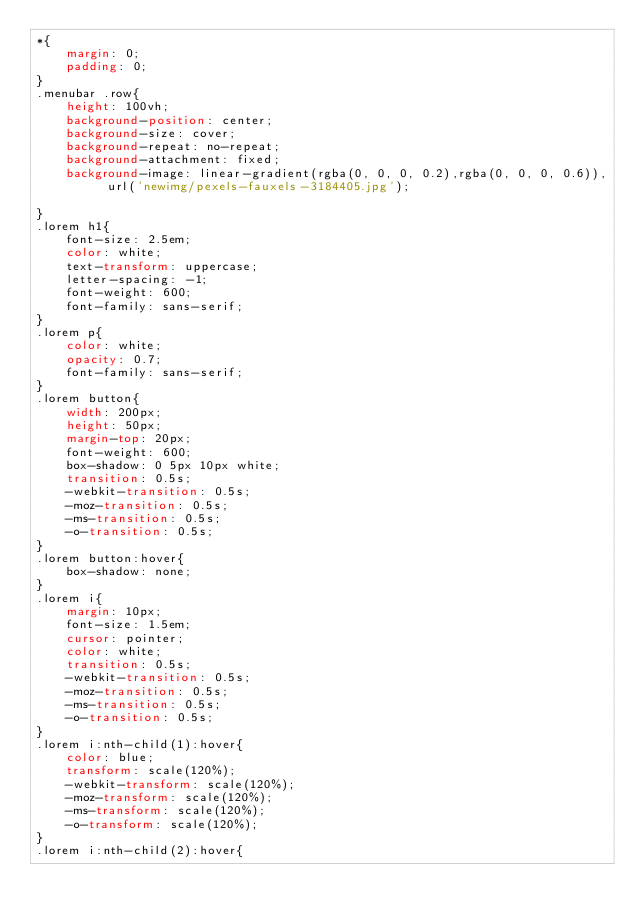Convert code to text. <code><loc_0><loc_0><loc_500><loc_500><_CSS_>*{
    margin: 0;
    padding: 0;
}
.menubar .row{
    height: 100vh;
    background-position: center;
    background-size: cover;
    background-repeat: no-repeat;
    background-attachment: fixed;
    background-image: linear-gradient(rgba(0, 0, 0, 0.2),rgba(0, 0, 0, 0.6)), url('newimg/pexels-fauxels-3184405.jpg');

}
.lorem h1{
    font-size: 2.5em;
    color: white;
    text-transform: uppercase;
    letter-spacing: -1;
    font-weight: 600;
    font-family: sans-serif;
}
.lorem p{
    color: white;
    opacity: 0.7;
    font-family: sans-serif;
}
.lorem button{
    width: 200px;
    height: 50px;
    margin-top: 20px;
    font-weight: 600;
    box-shadow: 0 5px 10px white;
    transition: 0.5s;
    -webkit-transition: 0.5s;
    -moz-transition: 0.5s;
    -ms-transition: 0.5s;
    -o-transition: 0.5s;
}
.lorem button:hover{
    box-shadow: none;
}
.lorem i{
    margin: 10px;
    font-size: 1.5em;
    cursor: pointer;
    color: white;
    transition: 0.5s;
    -webkit-transition: 0.5s;
    -moz-transition: 0.5s;
    -ms-transition: 0.5s;
    -o-transition: 0.5s;
}
.lorem i:nth-child(1):hover{
    color: blue;
    transform: scale(120%);
    -webkit-transform: scale(120%);
    -moz-transform: scale(120%);
    -ms-transform: scale(120%);
    -o-transform: scale(120%);
}
.lorem i:nth-child(2):hover{</code> 